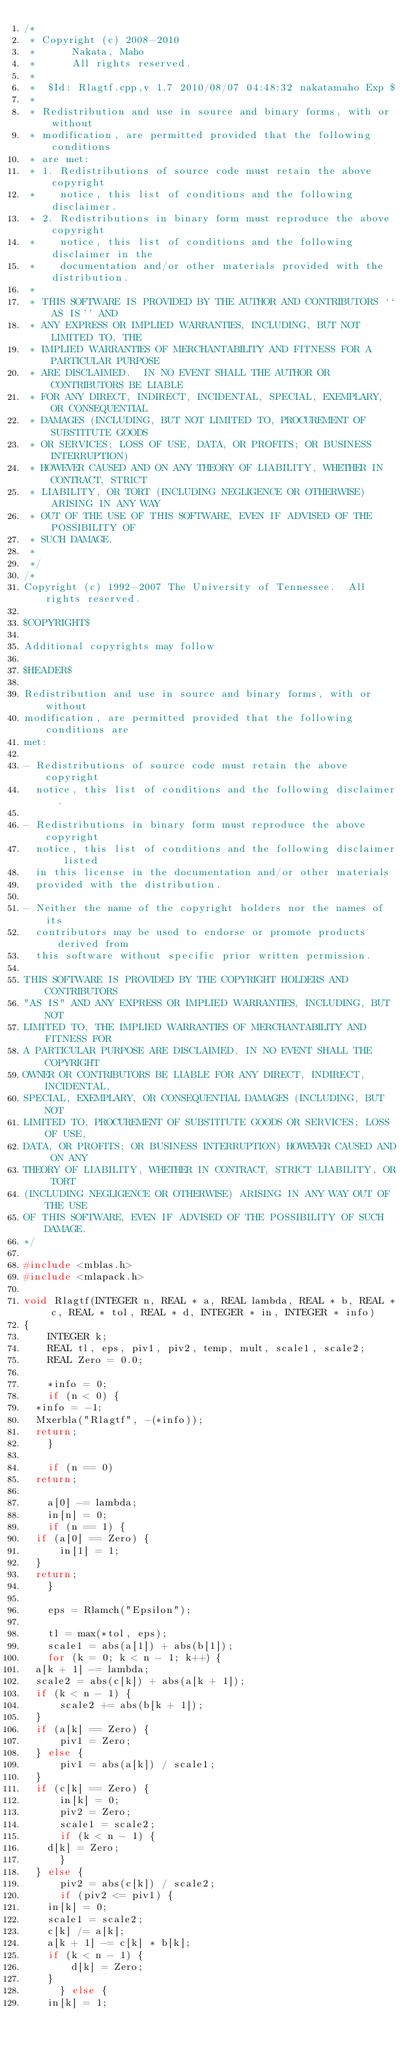<code> <loc_0><loc_0><loc_500><loc_500><_C++_>/*
 * Copyright (c) 2008-2010
 *      Nakata, Maho
 *      All rights reserved.
 *
 *  $Id: Rlagtf.cpp,v 1.7 2010/08/07 04:48:32 nakatamaho Exp $ 
 *
 * Redistribution and use in source and binary forms, with or without
 * modification, are permitted provided that the following conditions
 * are met:
 * 1. Redistributions of source code must retain the above copyright
 *    notice, this list of conditions and the following disclaimer.
 * 2. Redistributions in binary form must reproduce the above copyright
 *    notice, this list of conditions and the following disclaimer in the
 *    documentation and/or other materials provided with the distribution.
 *
 * THIS SOFTWARE IS PROVIDED BY THE AUTHOR AND CONTRIBUTORS ``AS IS'' AND
 * ANY EXPRESS OR IMPLIED WARRANTIES, INCLUDING, BUT NOT LIMITED TO, THE
 * IMPLIED WARRANTIES OF MERCHANTABILITY AND FITNESS FOR A PARTICULAR PURPOSE
 * ARE DISCLAIMED.  IN NO EVENT SHALL THE AUTHOR OR CONTRIBUTORS BE LIABLE
 * FOR ANY DIRECT, INDIRECT, INCIDENTAL, SPECIAL, EXEMPLARY, OR CONSEQUENTIAL
 * DAMAGES (INCLUDING, BUT NOT LIMITED TO, PROCUREMENT OF SUBSTITUTE GOODS
 * OR SERVICES; LOSS OF USE, DATA, OR PROFITS; OR BUSINESS INTERRUPTION)
 * HOWEVER CAUSED AND ON ANY THEORY OF LIABILITY, WHETHER IN CONTRACT, STRICT
 * LIABILITY, OR TORT (INCLUDING NEGLIGENCE OR OTHERWISE) ARISING IN ANY WAY
 * OUT OF THE USE OF THIS SOFTWARE, EVEN IF ADVISED OF THE POSSIBILITY OF
 * SUCH DAMAGE.
 *
 */
/*
Copyright (c) 1992-2007 The University of Tennessee.  All rights reserved.

$COPYRIGHT$

Additional copyrights may follow

$HEADER$

Redistribution and use in source and binary forms, with or without
modification, are permitted provided that the following conditions are
met:

- Redistributions of source code must retain the above copyright
  notice, this list of conditions and the following disclaimer. 
  
- Redistributions in binary form must reproduce the above copyright
  notice, this list of conditions and the following disclaimer listed
  in this license in the documentation and/or other materials
  provided with the distribution.
  
- Neither the name of the copyright holders nor the names of its
  contributors may be used to endorse or promote products derived from
  this software without specific prior written permission.
  
THIS SOFTWARE IS PROVIDED BY THE COPYRIGHT HOLDERS AND CONTRIBUTORS
"AS IS" AND ANY EXPRESS OR IMPLIED WARRANTIES, INCLUDING, BUT NOT  
LIMITED TO, THE IMPLIED WARRANTIES OF MERCHANTABILITY AND FITNESS FOR
A PARTICULAR PURPOSE ARE DISCLAIMED. IN NO EVENT SHALL THE COPYRIGHT 
OWNER OR CONTRIBUTORS BE LIABLE FOR ANY DIRECT, INDIRECT, INCIDENTAL,
SPECIAL, EXEMPLARY, OR CONSEQUENTIAL DAMAGES (INCLUDING, BUT NOT
LIMITED TO, PROCUREMENT OF SUBSTITUTE GOODS OR SERVICES; LOSS OF USE,
DATA, OR PROFITS; OR BUSINESS INTERRUPTION) HOWEVER CAUSED AND ON ANY
THEORY OF LIABILITY, WHETHER IN CONTRACT, STRICT LIABILITY, OR TORT  
(INCLUDING NEGLIGENCE OR OTHERWISE) ARISING IN ANY WAY OUT OF THE USE
OF THIS SOFTWARE, EVEN IF ADVISED OF THE POSSIBILITY OF SUCH DAMAGE. 
*/

#include <mblas.h>
#include <mlapack.h>

void Rlagtf(INTEGER n, REAL * a, REAL lambda, REAL * b, REAL * c, REAL * tol, REAL * d, INTEGER * in, INTEGER * info)
{
    INTEGER k;
    REAL tl, eps, piv1, piv2, temp, mult, scale1, scale2;
    REAL Zero = 0.0;

    *info = 0;
    if (n < 0) {
	*info = -1;
	Mxerbla("Rlagtf", -(*info));
	return;
    }

    if (n == 0)
	return;

    a[0] -= lambda;
    in[n] = 0;
    if (n == 1) {
	if (a[0] == Zero) {
	    in[1] = 1;
	}
	return;
    }

    eps = Rlamch("Epsilon");

    tl = max(*tol, eps);
    scale1 = abs(a[1]) + abs(b[1]);
    for (k = 0; k < n - 1; k++) {
	a[k + 1] -= lambda;
	scale2 = abs(c[k]) + abs(a[k + 1]);
	if (k < n - 1) {
	    scale2 += abs(b[k + 1]);
	}
	if (a[k] == Zero) {
	    piv1 = Zero;
	} else {
	    piv1 = abs(a[k]) / scale1;
	}
	if (c[k] == Zero) {
	    in[k] = 0;
	    piv2 = Zero;
	    scale1 = scale2;
	    if (k < n - 1) {
		d[k] = Zero;
	    }
	} else {
	    piv2 = abs(c[k]) / scale2;
	    if (piv2 <= piv1) {
		in[k] = 0;
		scale1 = scale2;
		c[k] /= a[k];
		a[k + 1] -= c[k] * b[k];
		if (k < n - 1) {
		    d[k] = Zero;
		}
	    } else {
		in[k] = 1;</code> 